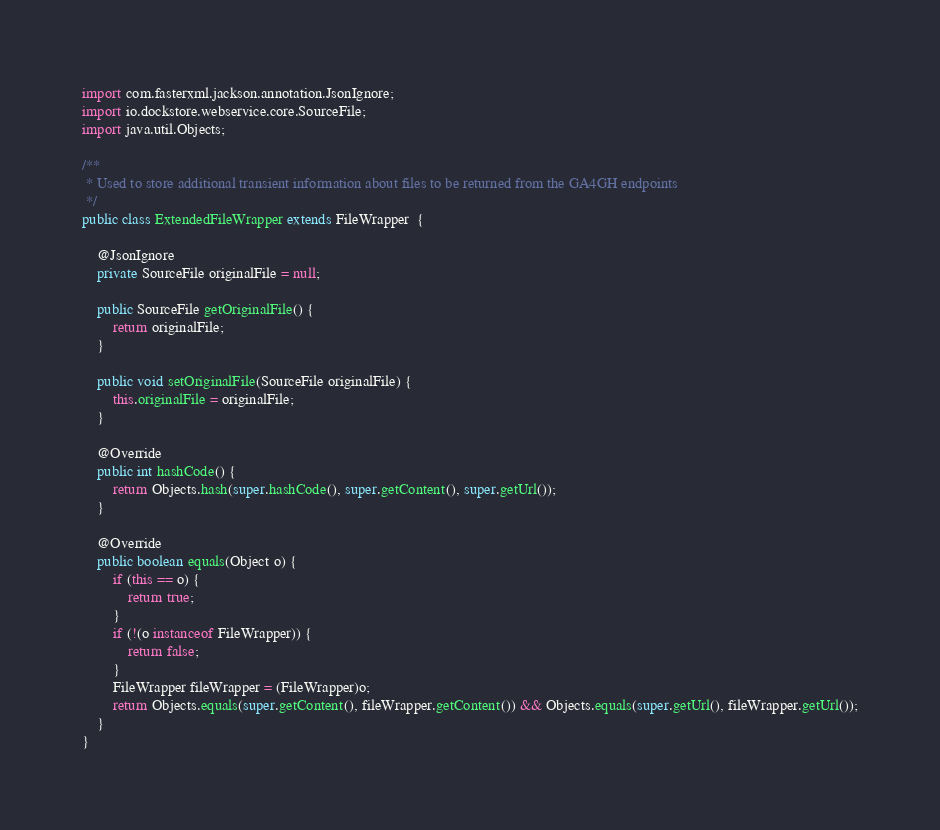Convert code to text. <code><loc_0><loc_0><loc_500><loc_500><_Java_>
import com.fasterxml.jackson.annotation.JsonIgnore;
import io.dockstore.webservice.core.SourceFile;
import java.util.Objects;

/**
 * Used to store additional transient information about files to be returned from the GA4GH endpoints
 */
public class ExtendedFileWrapper extends FileWrapper  {

    @JsonIgnore
    private SourceFile originalFile = null;

    public SourceFile getOriginalFile() {
        return originalFile;
    }

    public void setOriginalFile(SourceFile originalFile) {
        this.originalFile = originalFile;
    }

    @Override
    public int hashCode() {
        return Objects.hash(super.hashCode(), super.getContent(), super.getUrl());
    }

    @Override
    public boolean equals(Object o) {
        if (this == o) {
            return true;
        }
        if (!(o instanceof FileWrapper)) {
            return false;
        }
        FileWrapper fileWrapper = (FileWrapper)o;
        return Objects.equals(super.getContent(), fileWrapper.getContent()) && Objects.equals(super.getUrl(), fileWrapper.getUrl());
    }
}
</code> 